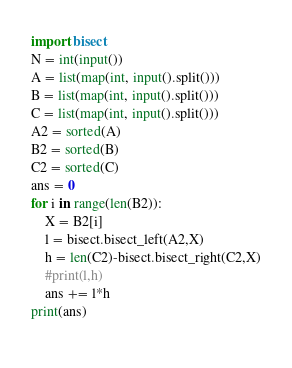<code> <loc_0><loc_0><loc_500><loc_500><_Python_>import bisect
N = int(input())
A = list(map(int, input().split()))
B = list(map(int, input().split()))
C = list(map(int, input().split()))
A2 = sorted(A)
B2 = sorted(B)
C2 = sorted(C)
ans = 0
for i in range(len(B2)):
    X = B2[i]
    l = bisect.bisect_left(A2,X)
    h = len(C2)-bisect.bisect_right(C2,X)
    #print(l,h)
    ans += l*h
print(ans)
               </code> 